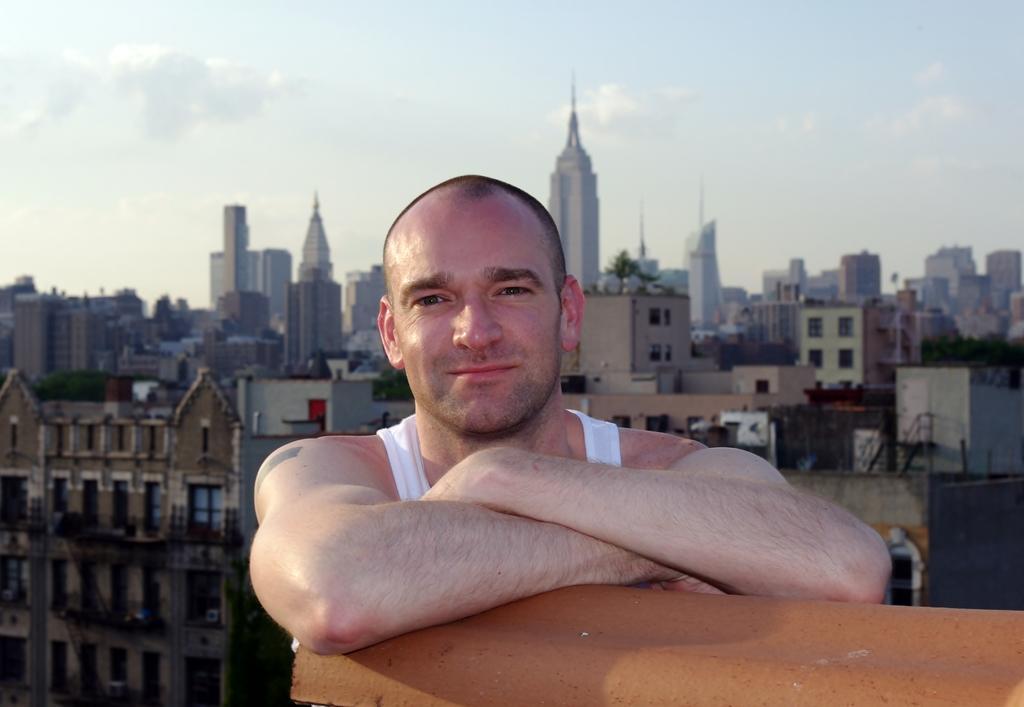Please provide a concise description of this image. In this image I see a man over here and I see the orange color thing over here. In the background I see number of buildings and I see the clear sky. 